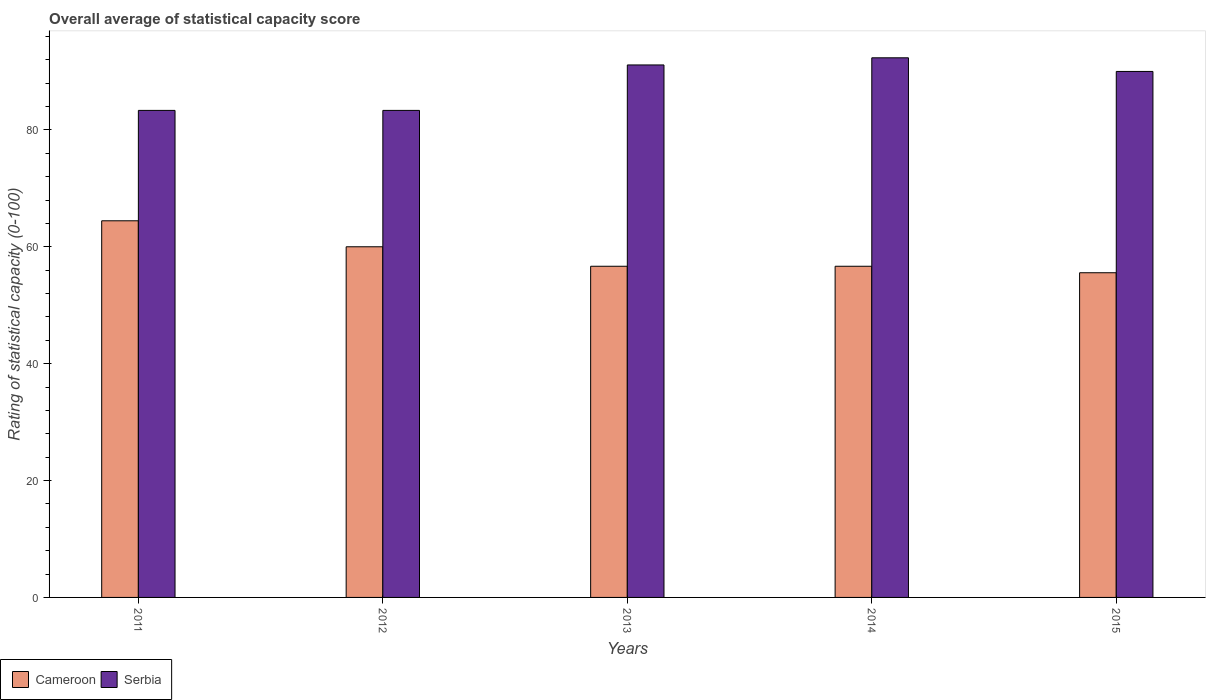Are the number of bars per tick equal to the number of legend labels?
Provide a succinct answer. Yes. How many bars are there on the 2nd tick from the left?
Your answer should be compact. 2. How many bars are there on the 3rd tick from the right?
Keep it short and to the point. 2. What is the label of the 2nd group of bars from the left?
Give a very brief answer. 2012. What is the rating of statistical capacity in Cameroon in 2011?
Offer a very short reply. 64.44. Across all years, what is the maximum rating of statistical capacity in Cameroon?
Your answer should be compact. 64.44. Across all years, what is the minimum rating of statistical capacity in Cameroon?
Make the answer very short. 55.56. In which year was the rating of statistical capacity in Serbia maximum?
Offer a very short reply. 2014. In which year was the rating of statistical capacity in Cameroon minimum?
Keep it short and to the point. 2015. What is the total rating of statistical capacity in Cameroon in the graph?
Provide a short and direct response. 293.33. What is the difference between the rating of statistical capacity in Cameroon in 2011 and that in 2015?
Your response must be concise. 8.89. What is the average rating of statistical capacity in Serbia per year?
Offer a terse response. 88.02. In the year 2011, what is the difference between the rating of statistical capacity in Cameroon and rating of statistical capacity in Serbia?
Keep it short and to the point. -18.89. What is the ratio of the rating of statistical capacity in Cameroon in 2011 to that in 2014?
Give a very brief answer. 1.14. Is the difference between the rating of statistical capacity in Cameroon in 2011 and 2015 greater than the difference between the rating of statistical capacity in Serbia in 2011 and 2015?
Give a very brief answer. Yes. What is the difference between the highest and the second highest rating of statistical capacity in Cameroon?
Offer a very short reply. 4.44. What does the 1st bar from the left in 2015 represents?
Provide a short and direct response. Cameroon. What does the 2nd bar from the right in 2012 represents?
Provide a succinct answer. Cameroon. Are all the bars in the graph horizontal?
Give a very brief answer. No. Are the values on the major ticks of Y-axis written in scientific E-notation?
Provide a succinct answer. No. Does the graph contain grids?
Your response must be concise. No. Where does the legend appear in the graph?
Your answer should be compact. Bottom left. How many legend labels are there?
Provide a succinct answer. 2. How are the legend labels stacked?
Make the answer very short. Horizontal. What is the title of the graph?
Provide a succinct answer. Overall average of statistical capacity score. What is the label or title of the X-axis?
Give a very brief answer. Years. What is the label or title of the Y-axis?
Ensure brevity in your answer.  Rating of statistical capacity (0-100). What is the Rating of statistical capacity (0-100) in Cameroon in 2011?
Offer a very short reply. 64.44. What is the Rating of statistical capacity (0-100) in Serbia in 2011?
Provide a short and direct response. 83.33. What is the Rating of statistical capacity (0-100) in Cameroon in 2012?
Your answer should be compact. 60. What is the Rating of statistical capacity (0-100) of Serbia in 2012?
Give a very brief answer. 83.33. What is the Rating of statistical capacity (0-100) in Cameroon in 2013?
Offer a terse response. 56.67. What is the Rating of statistical capacity (0-100) of Serbia in 2013?
Provide a short and direct response. 91.11. What is the Rating of statistical capacity (0-100) in Cameroon in 2014?
Ensure brevity in your answer.  56.67. What is the Rating of statistical capacity (0-100) of Serbia in 2014?
Ensure brevity in your answer.  92.33. What is the Rating of statistical capacity (0-100) of Cameroon in 2015?
Offer a terse response. 55.56. What is the Rating of statistical capacity (0-100) in Serbia in 2015?
Offer a very short reply. 90. Across all years, what is the maximum Rating of statistical capacity (0-100) of Cameroon?
Provide a succinct answer. 64.44. Across all years, what is the maximum Rating of statistical capacity (0-100) of Serbia?
Give a very brief answer. 92.33. Across all years, what is the minimum Rating of statistical capacity (0-100) of Cameroon?
Provide a succinct answer. 55.56. Across all years, what is the minimum Rating of statistical capacity (0-100) in Serbia?
Keep it short and to the point. 83.33. What is the total Rating of statistical capacity (0-100) in Cameroon in the graph?
Your answer should be compact. 293.33. What is the total Rating of statistical capacity (0-100) of Serbia in the graph?
Provide a short and direct response. 440.11. What is the difference between the Rating of statistical capacity (0-100) in Cameroon in 2011 and that in 2012?
Provide a short and direct response. 4.44. What is the difference between the Rating of statistical capacity (0-100) of Serbia in 2011 and that in 2012?
Offer a terse response. 0. What is the difference between the Rating of statistical capacity (0-100) of Cameroon in 2011 and that in 2013?
Your answer should be compact. 7.78. What is the difference between the Rating of statistical capacity (0-100) of Serbia in 2011 and that in 2013?
Make the answer very short. -7.78. What is the difference between the Rating of statistical capacity (0-100) in Cameroon in 2011 and that in 2014?
Provide a short and direct response. 7.78. What is the difference between the Rating of statistical capacity (0-100) in Cameroon in 2011 and that in 2015?
Your response must be concise. 8.89. What is the difference between the Rating of statistical capacity (0-100) in Serbia in 2011 and that in 2015?
Provide a succinct answer. -6.67. What is the difference between the Rating of statistical capacity (0-100) of Cameroon in 2012 and that in 2013?
Your answer should be very brief. 3.33. What is the difference between the Rating of statistical capacity (0-100) in Serbia in 2012 and that in 2013?
Offer a terse response. -7.78. What is the difference between the Rating of statistical capacity (0-100) of Cameroon in 2012 and that in 2014?
Provide a short and direct response. 3.33. What is the difference between the Rating of statistical capacity (0-100) in Serbia in 2012 and that in 2014?
Provide a succinct answer. -9. What is the difference between the Rating of statistical capacity (0-100) in Cameroon in 2012 and that in 2015?
Provide a succinct answer. 4.44. What is the difference between the Rating of statistical capacity (0-100) in Serbia in 2012 and that in 2015?
Keep it short and to the point. -6.67. What is the difference between the Rating of statistical capacity (0-100) of Cameroon in 2013 and that in 2014?
Your answer should be very brief. 0. What is the difference between the Rating of statistical capacity (0-100) of Serbia in 2013 and that in 2014?
Give a very brief answer. -1.22. What is the difference between the Rating of statistical capacity (0-100) of Serbia in 2013 and that in 2015?
Ensure brevity in your answer.  1.11. What is the difference between the Rating of statistical capacity (0-100) of Cameroon in 2014 and that in 2015?
Your response must be concise. 1.11. What is the difference between the Rating of statistical capacity (0-100) of Serbia in 2014 and that in 2015?
Offer a very short reply. 2.33. What is the difference between the Rating of statistical capacity (0-100) of Cameroon in 2011 and the Rating of statistical capacity (0-100) of Serbia in 2012?
Ensure brevity in your answer.  -18.89. What is the difference between the Rating of statistical capacity (0-100) of Cameroon in 2011 and the Rating of statistical capacity (0-100) of Serbia in 2013?
Keep it short and to the point. -26.67. What is the difference between the Rating of statistical capacity (0-100) in Cameroon in 2011 and the Rating of statistical capacity (0-100) in Serbia in 2014?
Ensure brevity in your answer.  -27.89. What is the difference between the Rating of statistical capacity (0-100) of Cameroon in 2011 and the Rating of statistical capacity (0-100) of Serbia in 2015?
Your answer should be compact. -25.56. What is the difference between the Rating of statistical capacity (0-100) in Cameroon in 2012 and the Rating of statistical capacity (0-100) in Serbia in 2013?
Give a very brief answer. -31.11. What is the difference between the Rating of statistical capacity (0-100) of Cameroon in 2012 and the Rating of statistical capacity (0-100) of Serbia in 2014?
Give a very brief answer. -32.33. What is the difference between the Rating of statistical capacity (0-100) of Cameroon in 2012 and the Rating of statistical capacity (0-100) of Serbia in 2015?
Offer a very short reply. -30. What is the difference between the Rating of statistical capacity (0-100) of Cameroon in 2013 and the Rating of statistical capacity (0-100) of Serbia in 2014?
Provide a short and direct response. -35.67. What is the difference between the Rating of statistical capacity (0-100) in Cameroon in 2013 and the Rating of statistical capacity (0-100) in Serbia in 2015?
Keep it short and to the point. -33.33. What is the difference between the Rating of statistical capacity (0-100) in Cameroon in 2014 and the Rating of statistical capacity (0-100) in Serbia in 2015?
Make the answer very short. -33.33. What is the average Rating of statistical capacity (0-100) of Cameroon per year?
Keep it short and to the point. 58.67. What is the average Rating of statistical capacity (0-100) in Serbia per year?
Keep it short and to the point. 88.02. In the year 2011, what is the difference between the Rating of statistical capacity (0-100) of Cameroon and Rating of statistical capacity (0-100) of Serbia?
Your answer should be very brief. -18.89. In the year 2012, what is the difference between the Rating of statistical capacity (0-100) in Cameroon and Rating of statistical capacity (0-100) in Serbia?
Your response must be concise. -23.33. In the year 2013, what is the difference between the Rating of statistical capacity (0-100) in Cameroon and Rating of statistical capacity (0-100) in Serbia?
Keep it short and to the point. -34.44. In the year 2014, what is the difference between the Rating of statistical capacity (0-100) of Cameroon and Rating of statistical capacity (0-100) of Serbia?
Provide a short and direct response. -35.67. In the year 2015, what is the difference between the Rating of statistical capacity (0-100) in Cameroon and Rating of statistical capacity (0-100) in Serbia?
Your answer should be compact. -34.44. What is the ratio of the Rating of statistical capacity (0-100) of Cameroon in 2011 to that in 2012?
Offer a terse response. 1.07. What is the ratio of the Rating of statistical capacity (0-100) of Serbia in 2011 to that in 2012?
Your answer should be very brief. 1. What is the ratio of the Rating of statistical capacity (0-100) of Cameroon in 2011 to that in 2013?
Your answer should be compact. 1.14. What is the ratio of the Rating of statistical capacity (0-100) of Serbia in 2011 to that in 2013?
Keep it short and to the point. 0.91. What is the ratio of the Rating of statistical capacity (0-100) of Cameroon in 2011 to that in 2014?
Ensure brevity in your answer.  1.14. What is the ratio of the Rating of statistical capacity (0-100) in Serbia in 2011 to that in 2014?
Your answer should be very brief. 0.9. What is the ratio of the Rating of statistical capacity (0-100) of Cameroon in 2011 to that in 2015?
Provide a succinct answer. 1.16. What is the ratio of the Rating of statistical capacity (0-100) of Serbia in 2011 to that in 2015?
Provide a succinct answer. 0.93. What is the ratio of the Rating of statistical capacity (0-100) in Cameroon in 2012 to that in 2013?
Offer a terse response. 1.06. What is the ratio of the Rating of statistical capacity (0-100) in Serbia in 2012 to that in 2013?
Your answer should be very brief. 0.91. What is the ratio of the Rating of statistical capacity (0-100) of Cameroon in 2012 to that in 2014?
Provide a succinct answer. 1.06. What is the ratio of the Rating of statistical capacity (0-100) in Serbia in 2012 to that in 2014?
Provide a succinct answer. 0.9. What is the ratio of the Rating of statistical capacity (0-100) in Serbia in 2012 to that in 2015?
Your response must be concise. 0.93. What is the ratio of the Rating of statistical capacity (0-100) of Serbia in 2013 to that in 2015?
Give a very brief answer. 1.01. What is the ratio of the Rating of statistical capacity (0-100) in Serbia in 2014 to that in 2015?
Offer a very short reply. 1.03. What is the difference between the highest and the second highest Rating of statistical capacity (0-100) in Cameroon?
Provide a short and direct response. 4.44. What is the difference between the highest and the second highest Rating of statistical capacity (0-100) in Serbia?
Offer a terse response. 1.22. What is the difference between the highest and the lowest Rating of statistical capacity (0-100) in Cameroon?
Offer a terse response. 8.89. 